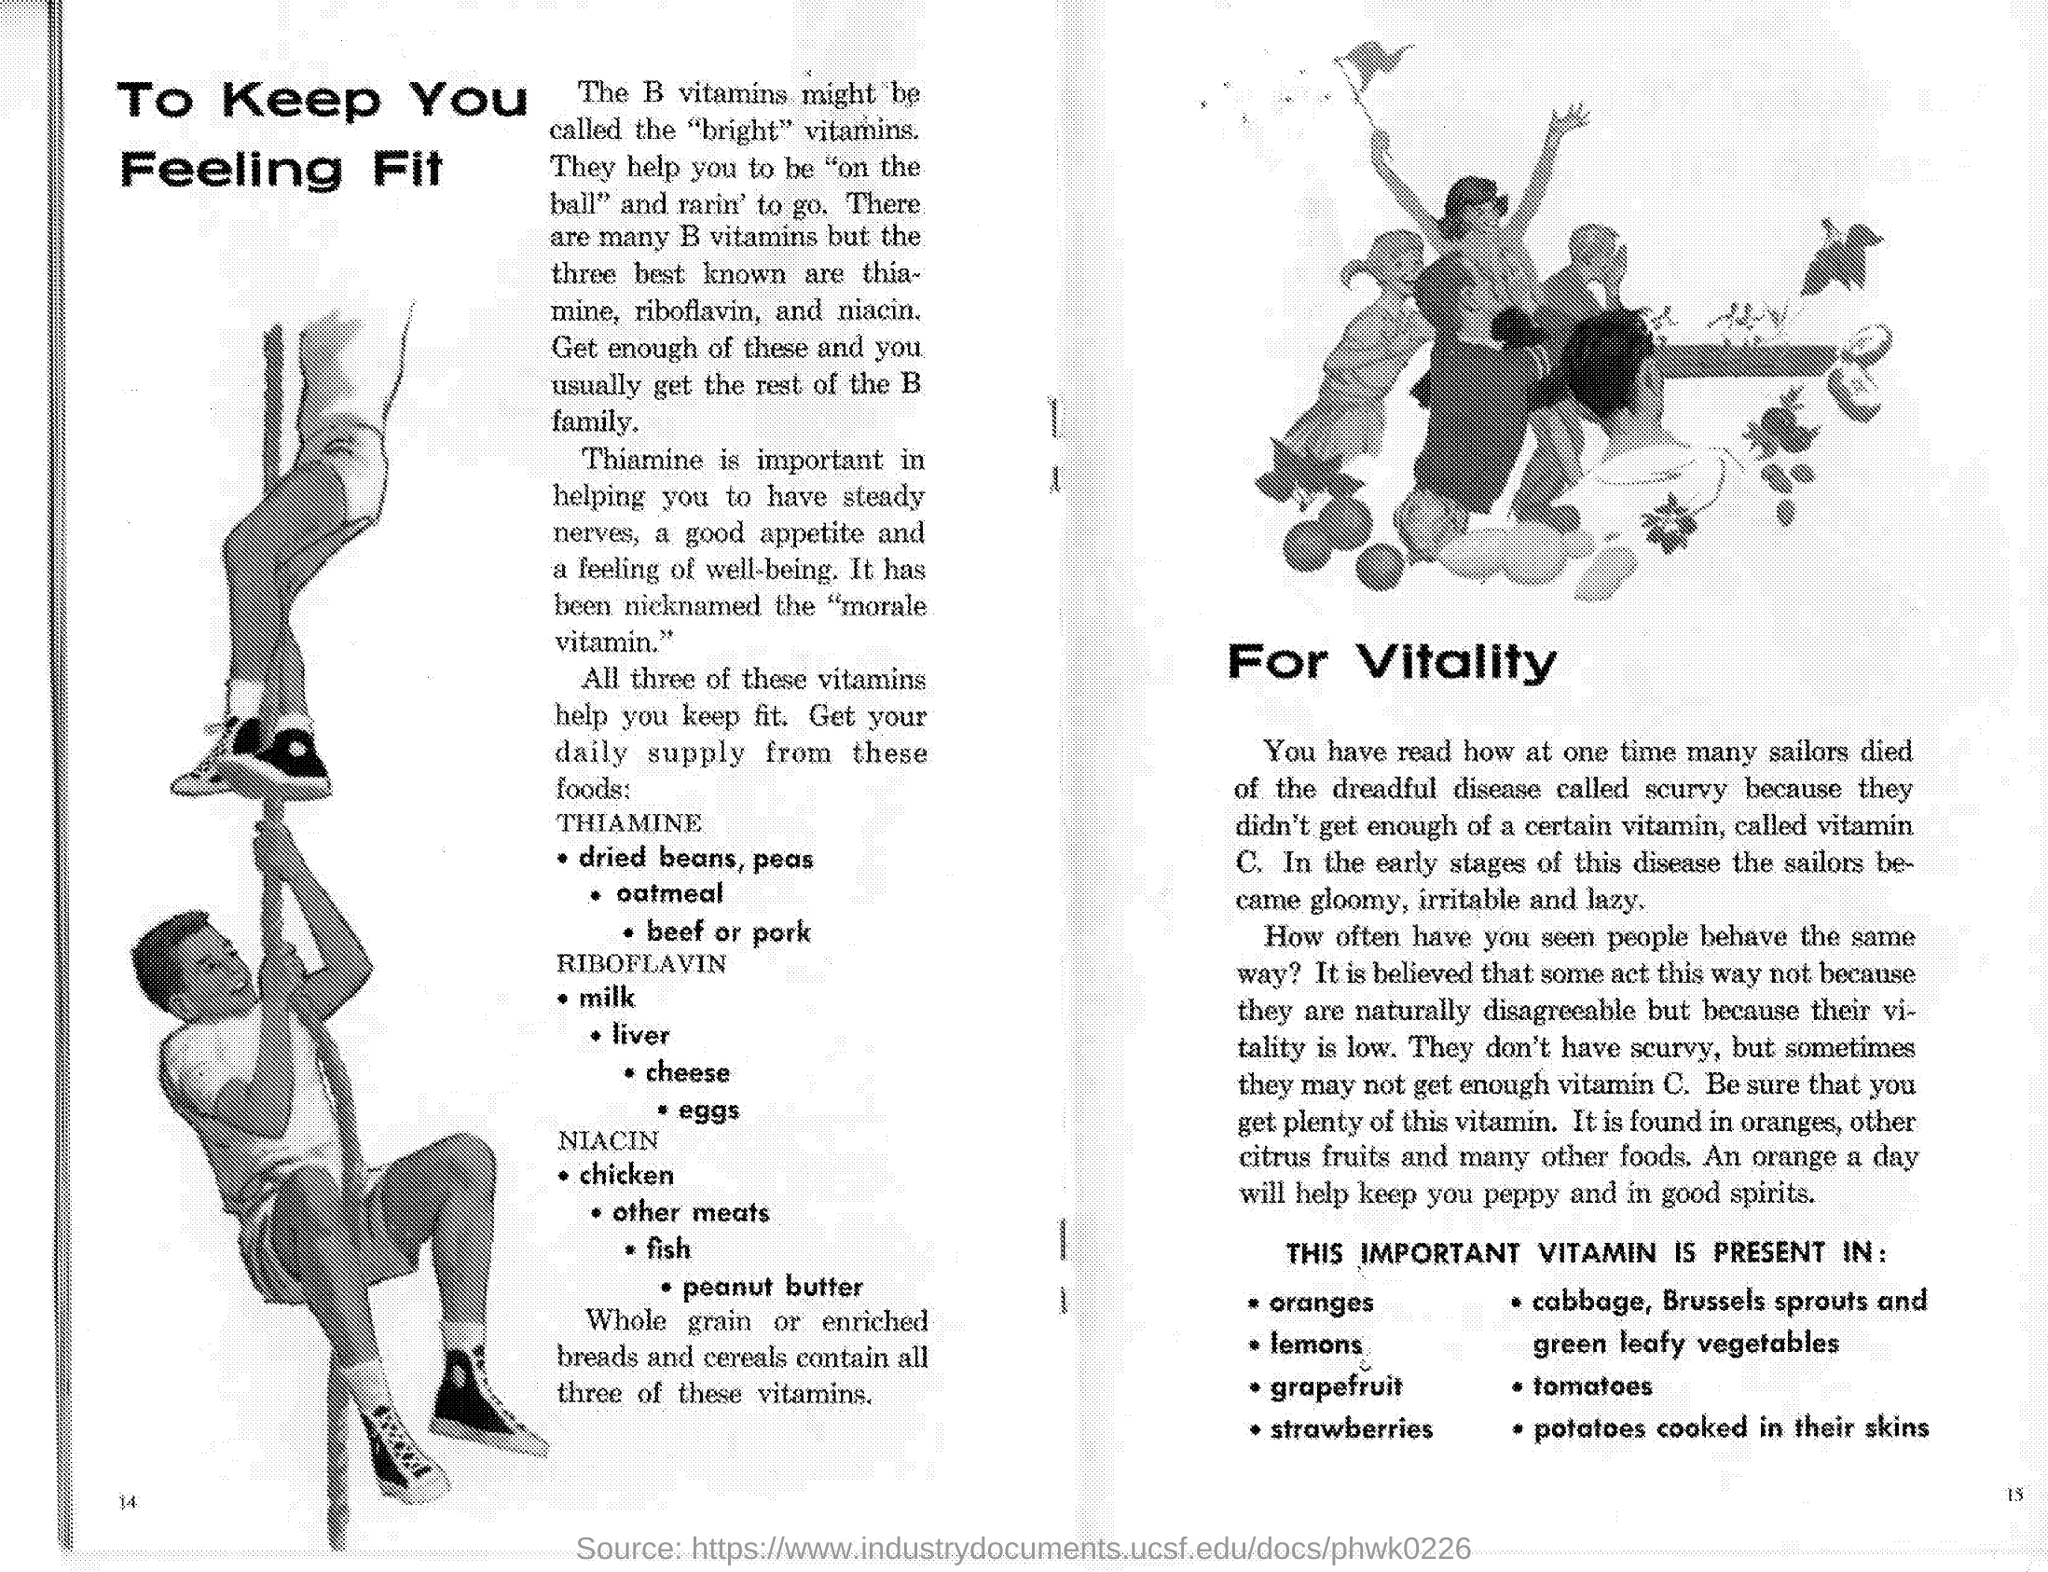Point out several critical features in this image. Thiamine is commonly referred to as the "moral vitamin. 